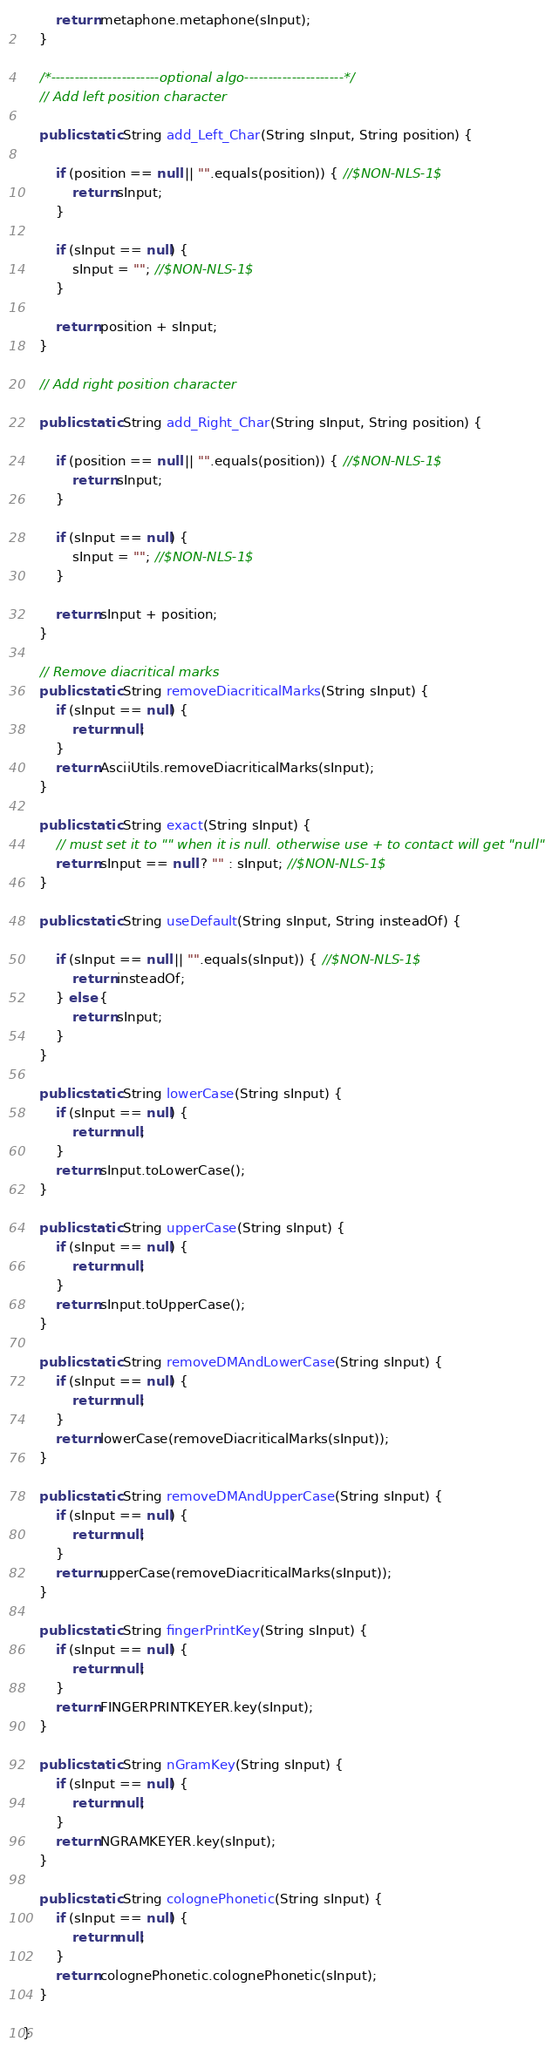Convert code to text. <code><loc_0><loc_0><loc_500><loc_500><_Java_>        return metaphone.metaphone(sInput);
    }

    /*-----------------------optional algo---------------------*/
    // Add left position character

    public static String add_Left_Char(String sInput, String position) {

        if (position == null || "".equals(position)) { //$NON-NLS-1$
            return sInput;
        }

        if (sInput == null) {
            sInput = ""; //$NON-NLS-1$
        }

        return position + sInput;
    }

    // Add right position character

    public static String add_Right_Char(String sInput, String position) {

        if (position == null || "".equals(position)) { //$NON-NLS-1$
            return sInput;
        }

        if (sInput == null) {
            sInput = ""; //$NON-NLS-1$
        }

        return sInput + position;
    }

    // Remove diacritical marks
    public static String removeDiacriticalMarks(String sInput) {
        if (sInput == null) {
            return null;
        }
        return AsciiUtils.removeDiacriticalMarks(sInput);
    }

    public static String exact(String sInput) {
        // must set it to "" when it is null. otherwise use + to contact will get "null"
        return sInput == null ? "" : sInput; //$NON-NLS-1$
    }

    public static String useDefault(String sInput, String insteadOf) {

        if (sInput == null || "".equals(sInput)) { //$NON-NLS-1$
            return insteadOf;
        } else {
            return sInput;
        }
    }

    public static String lowerCase(String sInput) {
        if (sInput == null) {
            return null;
        }
        return sInput.toLowerCase();
    }

    public static String upperCase(String sInput) {
        if (sInput == null) {
            return null;
        }
        return sInput.toUpperCase();
    }

    public static String removeDMAndLowerCase(String sInput) {
        if (sInput == null) {
            return null;
        }
        return lowerCase(removeDiacriticalMarks(sInput));
    }

    public static String removeDMAndUpperCase(String sInput) {
        if (sInput == null) {
            return null;
        }
        return upperCase(removeDiacriticalMarks(sInput));
    }

    public static String fingerPrintKey(String sInput) {
        if (sInput == null) {
            return null;
        }
        return FINGERPRINTKEYER.key(sInput);
    }

    public static String nGramKey(String sInput) {
        if (sInput == null) {
            return null;
        }
        return NGRAMKEYER.key(sInput);
    }

    public static String colognePhonetic(String sInput) {
        if (sInput == null) {
            return null;
        }
        return colognePhonetic.colognePhonetic(sInput);
    }

}
</code> 